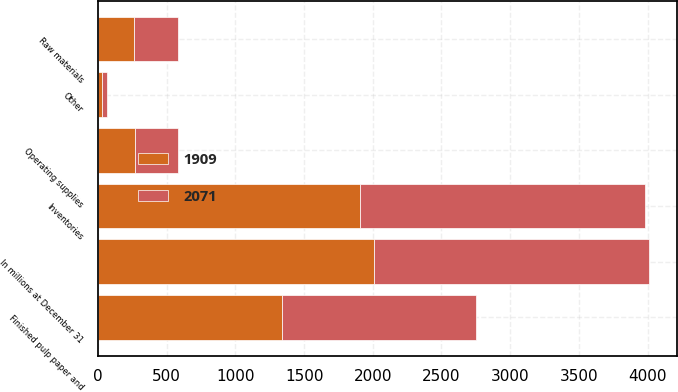Convert chart to OTSL. <chart><loc_0><loc_0><loc_500><loc_500><stacked_bar_chart><ecel><fcel>In millions at December 31<fcel>Raw materials<fcel>Finished pulp paper and<fcel>Operating supplies<fcel>Other<fcel>Inventories<nl><fcel>2071<fcel>2007<fcel>320<fcel>1413<fcel>308<fcel>30<fcel>2071<nl><fcel>1909<fcel>2006<fcel>265<fcel>1341<fcel>271<fcel>32<fcel>1909<nl></chart> 